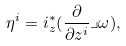<formula> <loc_0><loc_0><loc_500><loc_500>\eta ^ { i } = i _ { z } ^ { * } ( \frac { \partial } { \partial z ^ { i } } \lrcorner \omega ) ,</formula> 